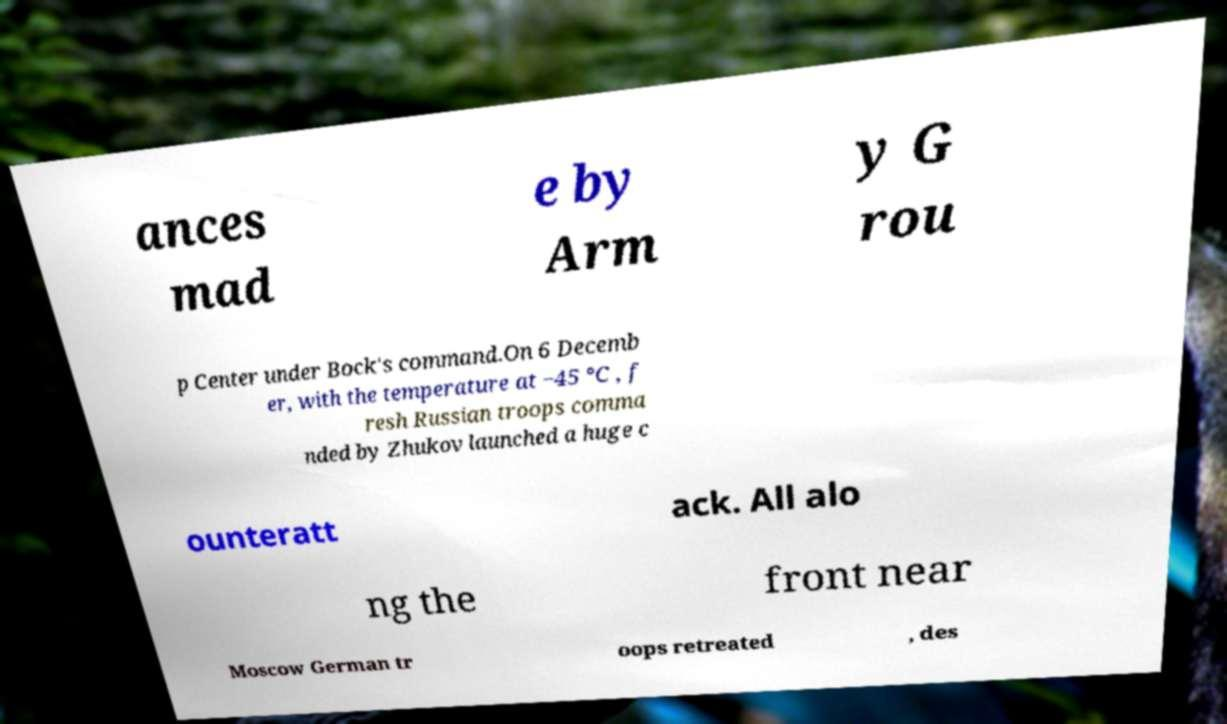Could you assist in decoding the text presented in this image and type it out clearly? ances mad e by Arm y G rou p Center under Bock's command.On 6 Decemb er, with the temperature at −45 °C , f resh Russian troops comma nded by Zhukov launched a huge c ounteratt ack. All alo ng the front near Moscow German tr oops retreated , des 